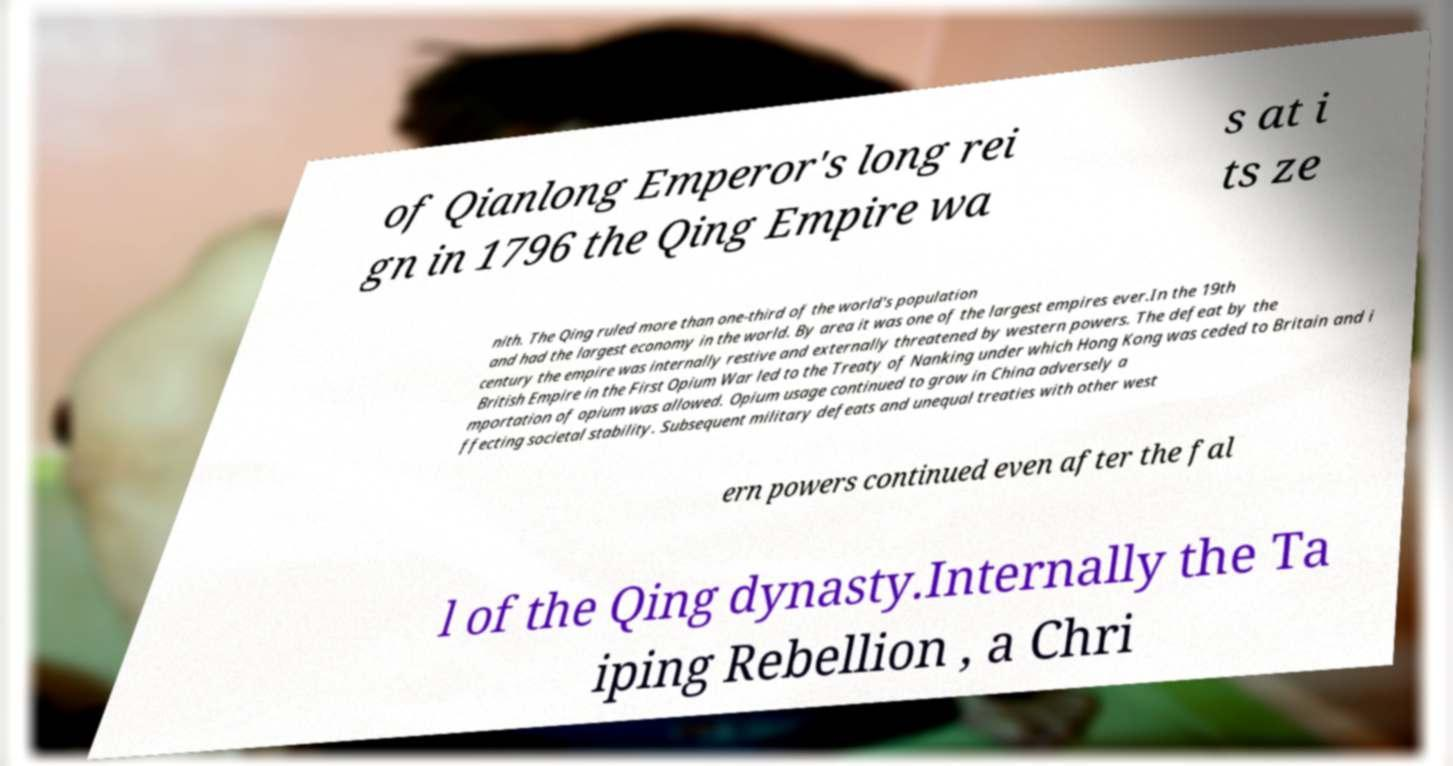Could you assist in decoding the text presented in this image and type it out clearly? of Qianlong Emperor's long rei gn in 1796 the Qing Empire wa s at i ts ze nith. The Qing ruled more than one-third of the world's population and had the largest economy in the world. By area it was one of the largest empires ever.In the 19th century the empire was internally restive and externally threatened by western powers. The defeat by the British Empire in the First Opium War led to the Treaty of Nanking under which Hong Kong was ceded to Britain and i mportation of opium was allowed. Opium usage continued to grow in China adversely a ffecting societal stability. Subsequent military defeats and unequal treaties with other west ern powers continued even after the fal l of the Qing dynasty.Internally the Ta iping Rebellion , a Chri 